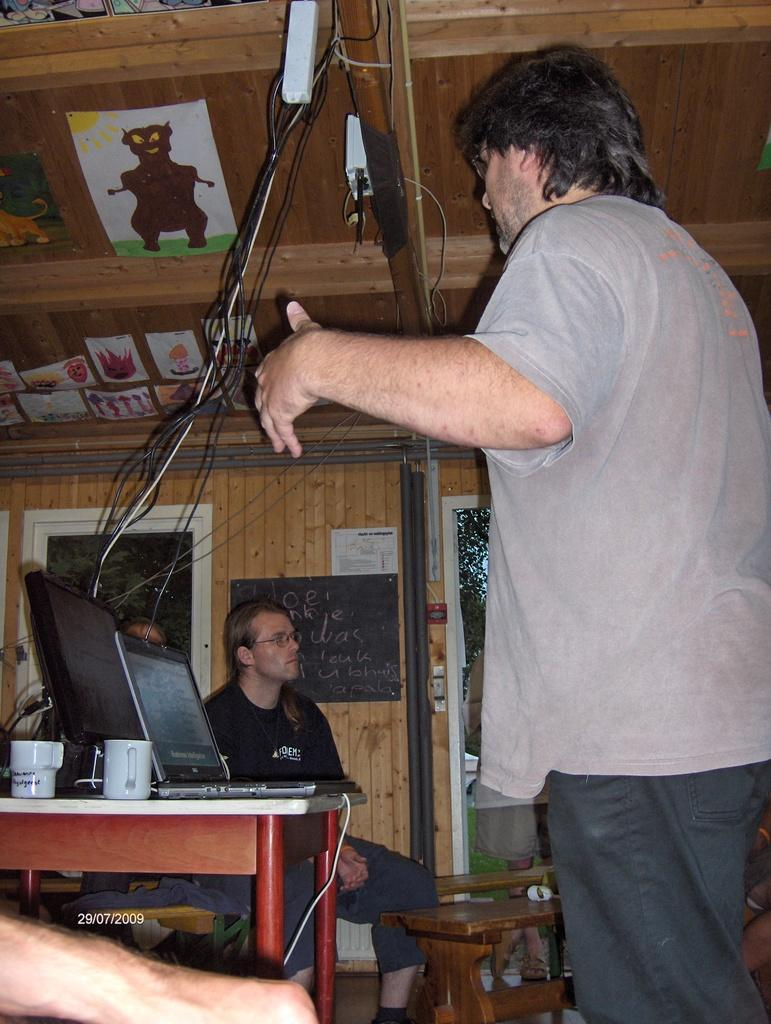How many people are present in the image? There are people in the image, but the exact number is not specified. What is on the table in the image? There is a table with cups in the image. What electronic device is visible in the image? There is a laptop in the image. What is on the table along with the laptop? There is a monitor on the table. What can be seen in the background of the image? There are posters, cables, a window, trees, and some unspecified objects in the background of the image. What type of farm animals can be seen in the image? There are no farm animals present in the image. How does the team breathe in the image? There is no team present in the image, and therefore, there is no one to breathe. 